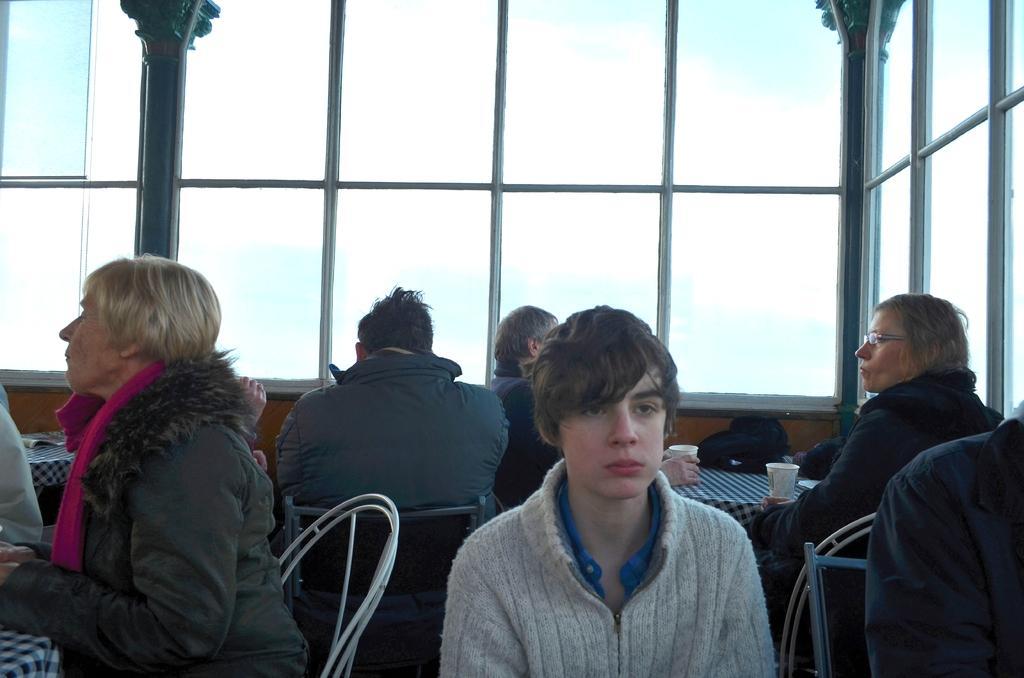How would you summarize this image in a sentence or two? In this image I can see few people are sitting on chairs and wearing different color dresses. I can see cups and few objects on the table. Back I can see few glass windows and pillars. 